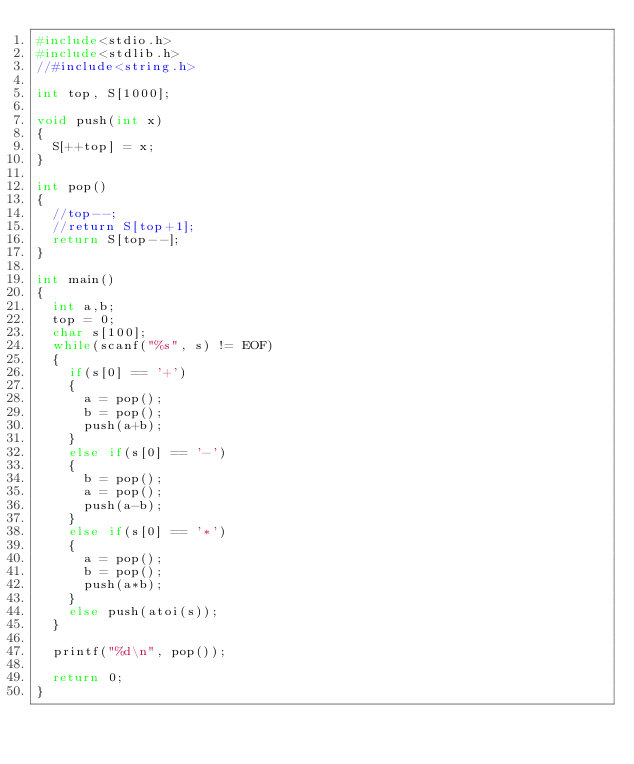Convert code to text. <code><loc_0><loc_0><loc_500><loc_500><_C_>#include<stdio.h>
#include<stdlib.h>
//#include<string.h>

int top, S[1000];

void push(int x)
{
  S[++top] = x;
}

int pop()
{
  //top--;
  //return S[top+1];
  return S[top--];
}

int main()
{
  int a,b;
  top = 0;
  char s[100];
  while(scanf("%s", s) != EOF)
  {
    if(s[0] == '+')
    {
      a = pop();
      b = pop();
      push(a+b);
    }
    else if(s[0] == '-')
    {
      b = pop();
      a = pop();
      push(a-b);
    }
    else if(s[0] == '*')
    {
      a = pop();
      b = pop();
      push(a*b);
    }
    else push(atoi(s));
  }

  printf("%d\n", pop());

  return 0;
}

</code> 